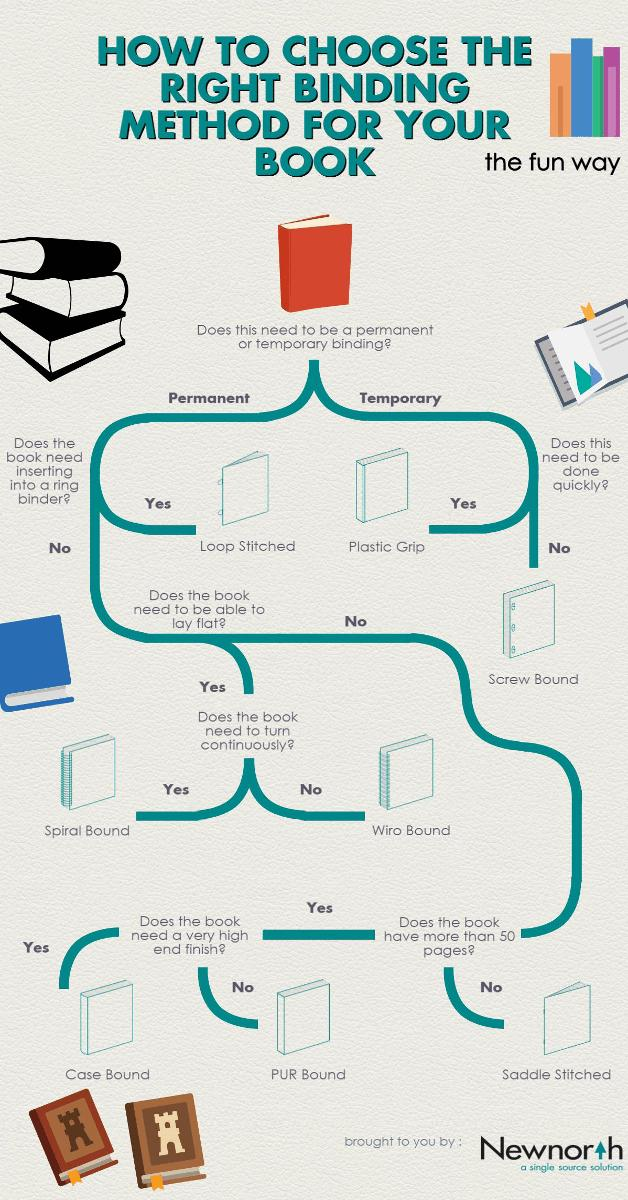Specify some key components in this picture. It is best to use a spiral binding for a book that requires continuous turning, as it provides a secure and flexible way to lay the pages open flat. For a book that requires an exceptionally high-end finish, case binding is the superior binding choice. It is recommended to use plastic grip fasteners for temporary binding as they are quick and efficient. The loop stitched binding method is the most suitable for the permanent binding of a book in which books need to insert into a ring binder, as it allows for easy insertion and removal of the book while maintaining its structural integrity. 